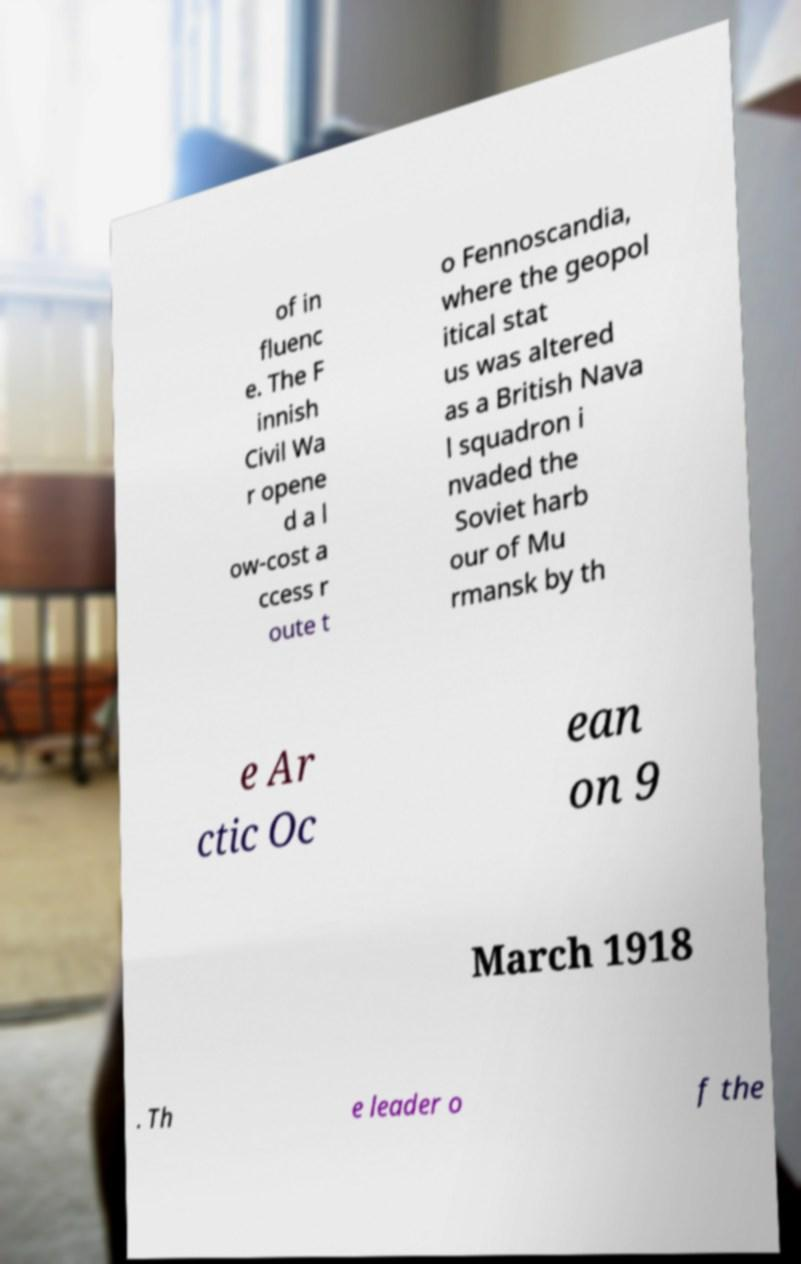Please read and relay the text visible in this image. What does it say? of in fluenc e. The F innish Civil Wa r opene d a l ow-cost a ccess r oute t o Fennoscandia, where the geopol itical stat us was altered as a British Nava l squadron i nvaded the Soviet harb our of Mu rmansk by th e Ar ctic Oc ean on 9 March 1918 . Th e leader o f the 